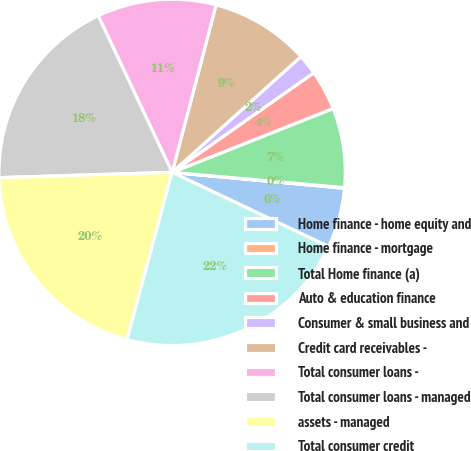Convert chart to OTSL. <chart><loc_0><loc_0><loc_500><loc_500><pie_chart><fcel>Home finance - home equity and<fcel>Home finance - mortgage<fcel>Total Home finance (a)<fcel>Auto & education finance<fcel>Consumer & small business and<fcel>Credit card receivables -<fcel>Total consumer loans -<fcel>Total consumer loans - managed<fcel>assets - managed<fcel>Total consumer credit<nl><fcel>5.58%<fcel>0.06%<fcel>7.42%<fcel>3.74%<fcel>1.9%<fcel>9.26%<fcel>11.1%<fcel>18.47%<fcel>20.31%<fcel>22.15%<nl></chart> 